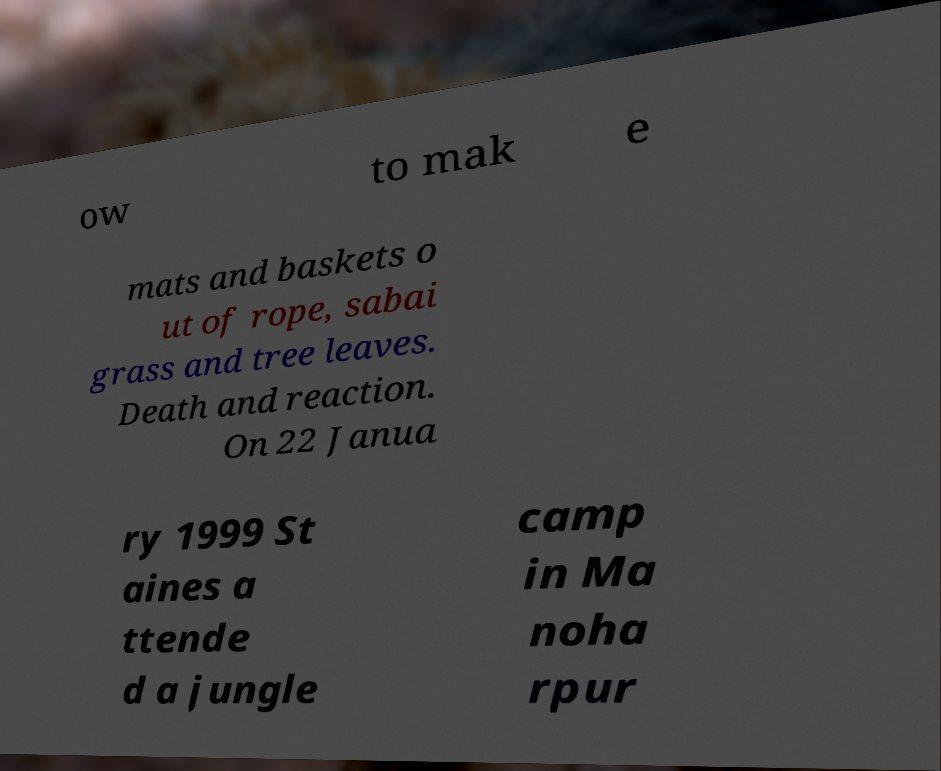What messages or text are displayed in this image? I need them in a readable, typed format. ow to mak e mats and baskets o ut of rope, sabai grass and tree leaves. Death and reaction. On 22 Janua ry 1999 St aines a ttende d a jungle camp in Ma noha rpur 